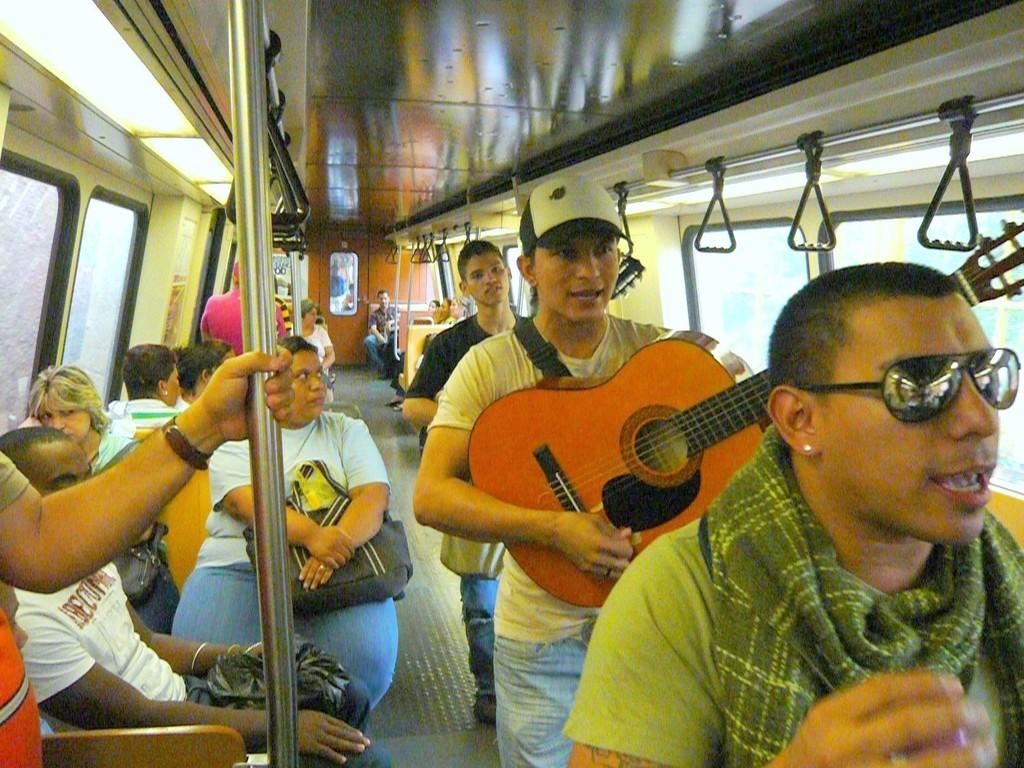How many people are in the image? There are persons in the image, but the exact number is not specified. What are the persons doing in the image? Some of the persons are sitting on seats, while others are standing and holding guitars in their hands. Where are the persons located in the image? The persons are inside a vehicle. What type of key is used to play the guitar in the image? There is no key present in the image, as guitars are typically played using fingers or a pick. Can you see a needle in the image? There is no mention of a needle in the provided facts, so it cannot be determined if one is present in the image. 